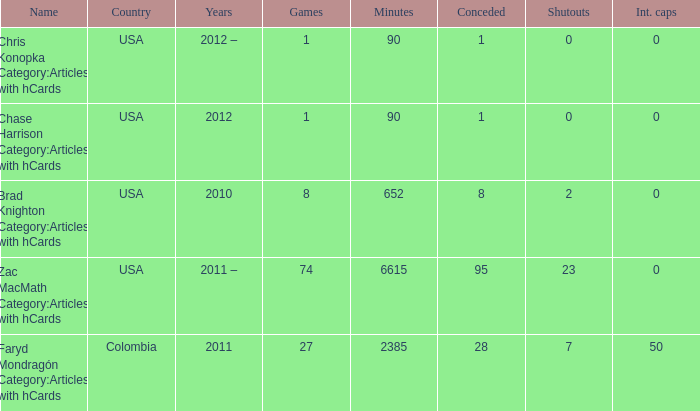When  chris konopka category:articles with hcards is the name what is the year? 2012 –. 